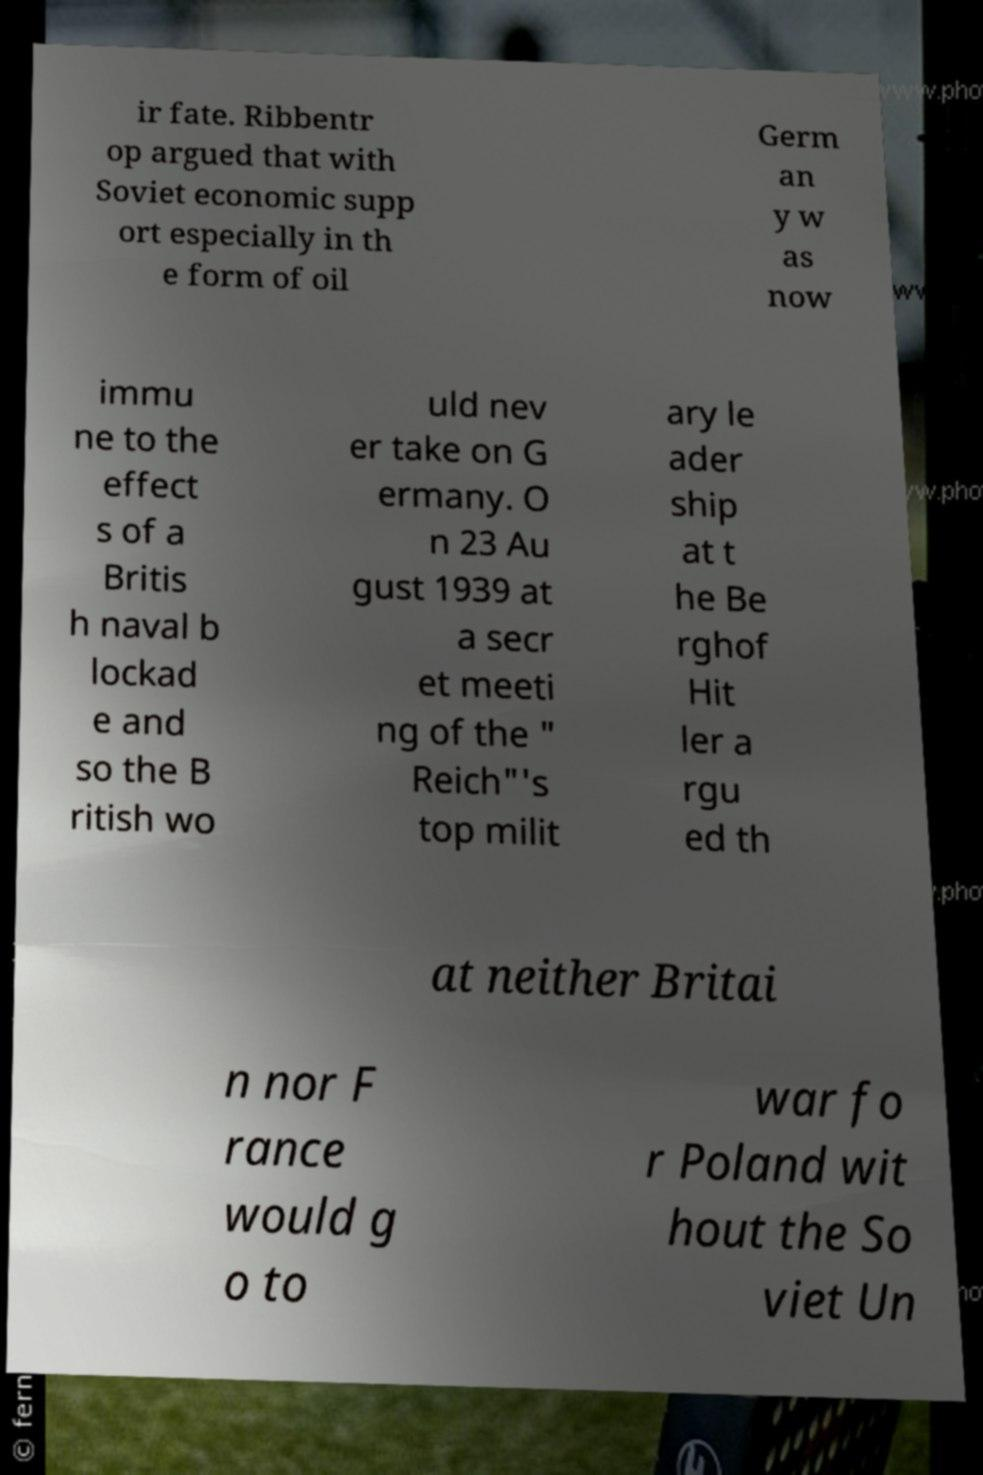For documentation purposes, I need the text within this image transcribed. Could you provide that? ir fate. Ribbentr op argued that with Soviet economic supp ort especially in th e form of oil Germ an y w as now immu ne to the effect s of a Britis h naval b lockad e and so the B ritish wo uld nev er take on G ermany. O n 23 Au gust 1939 at a secr et meeti ng of the " Reich"'s top milit ary le ader ship at t he Be rghof Hit ler a rgu ed th at neither Britai n nor F rance would g o to war fo r Poland wit hout the So viet Un 